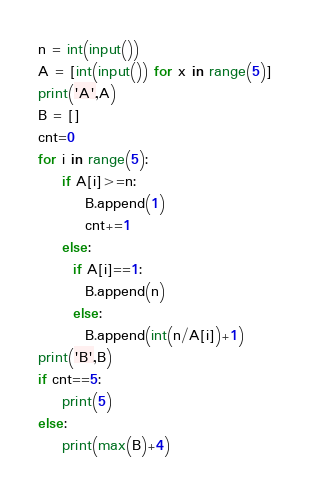<code> <loc_0><loc_0><loc_500><loc_500><_Python_>n = int(input())
A = [int(input()) for x in range(5)]
print('A',A)
B = []
cnt=0
for i in range(5):
    if A[i]>=n:
        B.append(1)
        cnt+=1
    else:
      if A[i]==1:
        B.append(n)
      else:
        B.append(int(n/A[i])+1)
print('B',B)
if cnt==5:
    print(5)
else:
    print(max(B)+4)</code> 